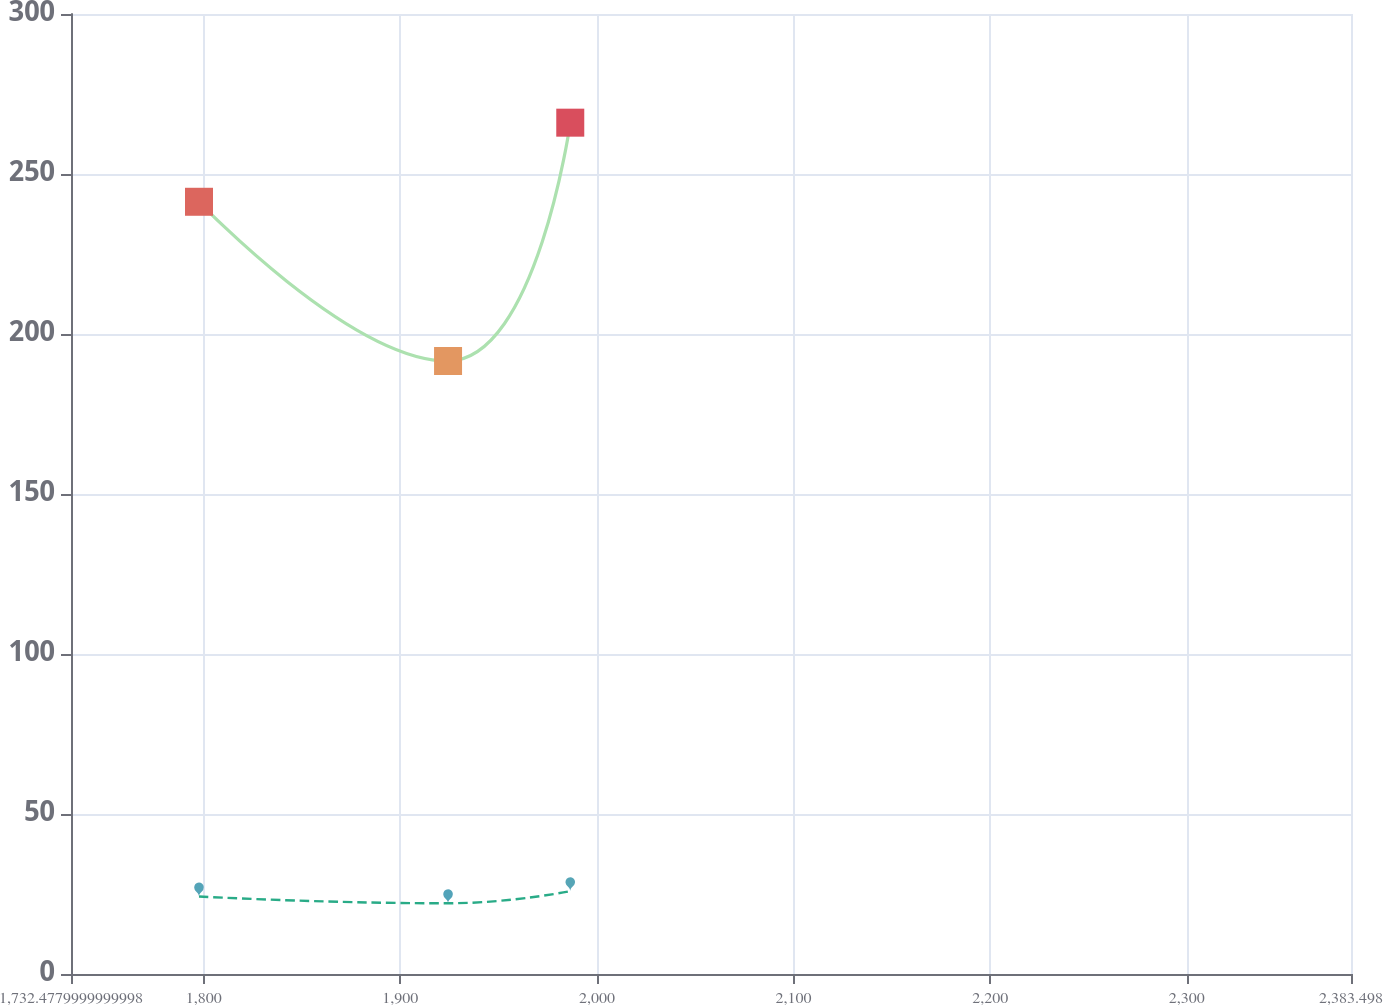Convert chart to OTSL. <chart><loc_0><loc_0><loc_500><loc_500><line_chart><ecel><fcel>Pension Benefits<fcel>Other Postretirement Benefits<nl><fcel>1797.58<fcel>241.32<fcel>24.22<nl><fcel>1924.25<fcel>191.56<fcel>22.1<nl><fcel>1986.41<fcel>266.04<fcel>25.89<nl><fcel>2386.44<fcel>217.08<fcel>21.38<nl><fcel>2448.6<fcel>201.78<fcel>20.75<nl></chart> 